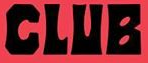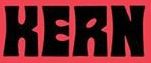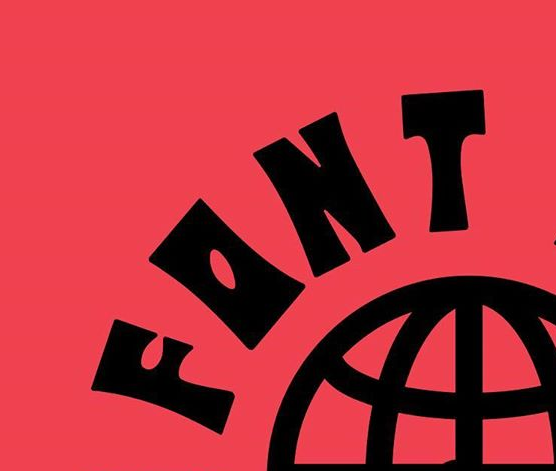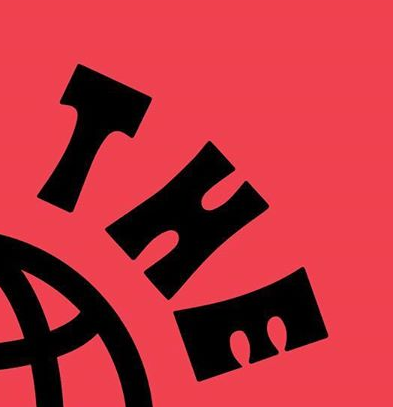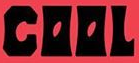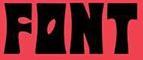What text is displayed in these images sequentially, separated by a semicolon? CLUB; KERN; FONT; THE; COOL; FONT 